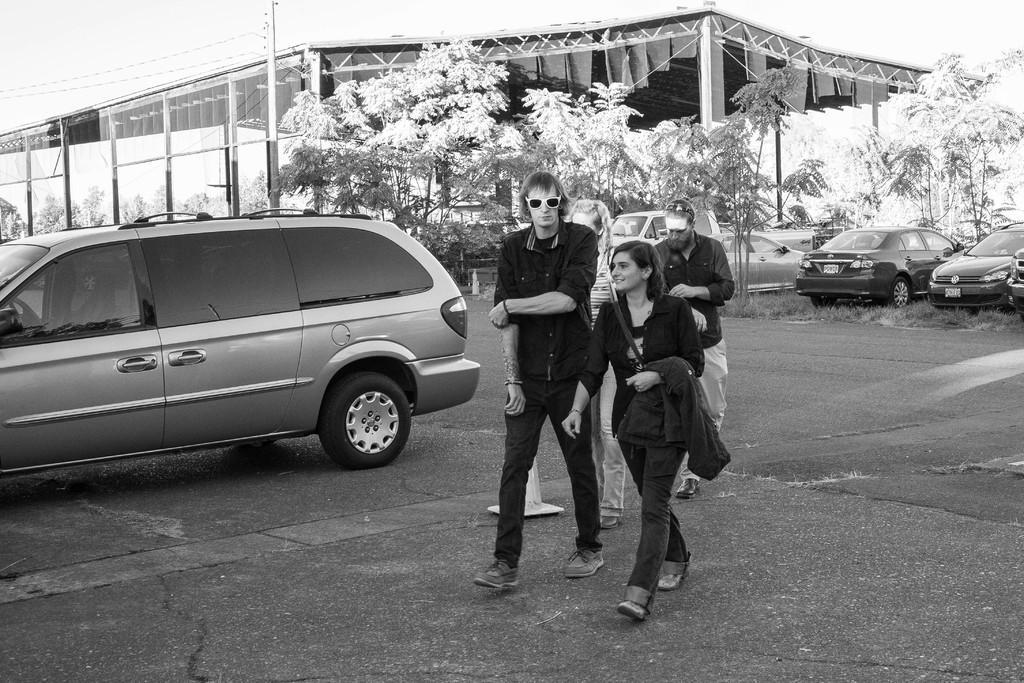Could you give a brief overview of what you see in this image? In this image I can see group of people walking, background I can see few vehicles, trees and I can also see the shed and the image is in black and white. 